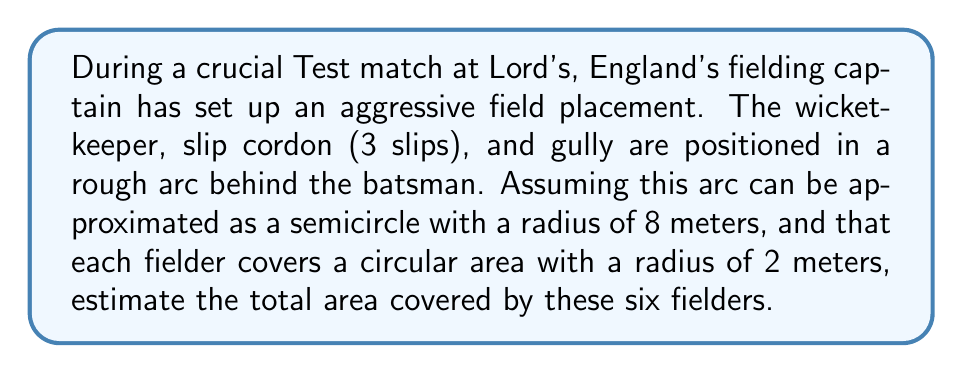What is the answer to this math problem? Let's approach this problem step-by-step:

1) First, we need to calculate the area of the semicircle formed by the fielders' positions:
   Area of semicircle = $\frac{1}{2} \pi r^2$
   Where $r = 8$ meters
   $$A_{semicircle} = \frac{1}{2} \pi (8)^2 = 32\pi \approx 100.53 \text{ m}^2$$

2) Now, we calculate the area covered by each fielder:
   Area covered by one fielder = $\pi r^2$
   Where $r = 2$ meters
   $$A_{fielder} = \pi (2)^2 = 4\pi \approx 12.57 \text{ m}^2$$

3) There are 6 fielders in total (wicket-keeper, 3 slips, gully, and one more), so the total area covered by the fielders is:
   $$A_{total} = 6 \times 4\pi = 24\pi \approx 75.40 \text{ m}^2$$

4) However, some of this area overlaps with the semicircle we calculated earlier. A good estimate would be that about half of each fielder's area is within the semicircle. So we need to add half of the fielders' total area to half of the semicircle area:

   $$A_{estimate} = \frac{1}{2}(32\pi) + \frac{1}{2}(24\pi) = 28\pi \approx 87.96 \text{ m}^2$$

[asy]
import geometry;

size(200);
draw(scale(8)*unitcircle,blue);
fill(scale(8)*unitcircle,blue+opacity(0.1));
for(int i=0; i<6; ++i) {
  pair p = 8*dir(180-30*i);
  fill(circle(p,2),red+opacity(0.3));
  draw(circle(p,2),red);
}
draw((-8,0)--(8,0),dashed);
label("8m",(-4,0),N);
[/asy]
Answer: The estimated area covered by the six fielders is approximately $28\pi \approx 87.96 \text{ m}^2$. 